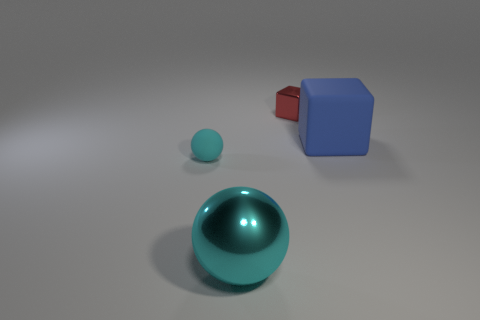How many things are either blue things or small objects behind the big rubber object?
Provide a succinct answer. 2. There is a object that is to the right of the shiny block that is right of the big ball; how many cyan metallic balls are in front of it?
Ensure brevity in your answer.  1. Is the shape of the tiny object in front of the small red cube the same as  the small red thing?
Your response must be concise. No. Are there any small cubes left of the big thing that is left of the large blue matte thing?
Your answer should be very brief. No. What number of large things are there?
Provide a short and direct response. 2. There is a thing that is in front of the big blue block and behind the cyan shiny sphere; what is its color?
Your answer should be compact. Cyan. What size is the other thing that is the same shape as the small cyan rubber object?
Provide a succinct answer. Large. How many matte cubes are the same size as the blue matte object?
Give a very brief answer. 0. What is the large blue object made of?
Ensure brevity in your answer.  Rubber. Are there any large objects to the right of the tiny red metal object?
Ensure brevity in your answer.  Yes. 